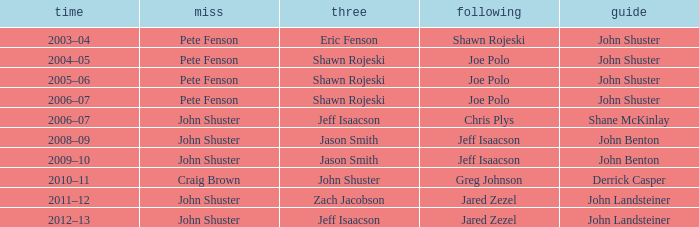Who was the lead with John Shuster as skip in the season of 2009–10? John Benton. 